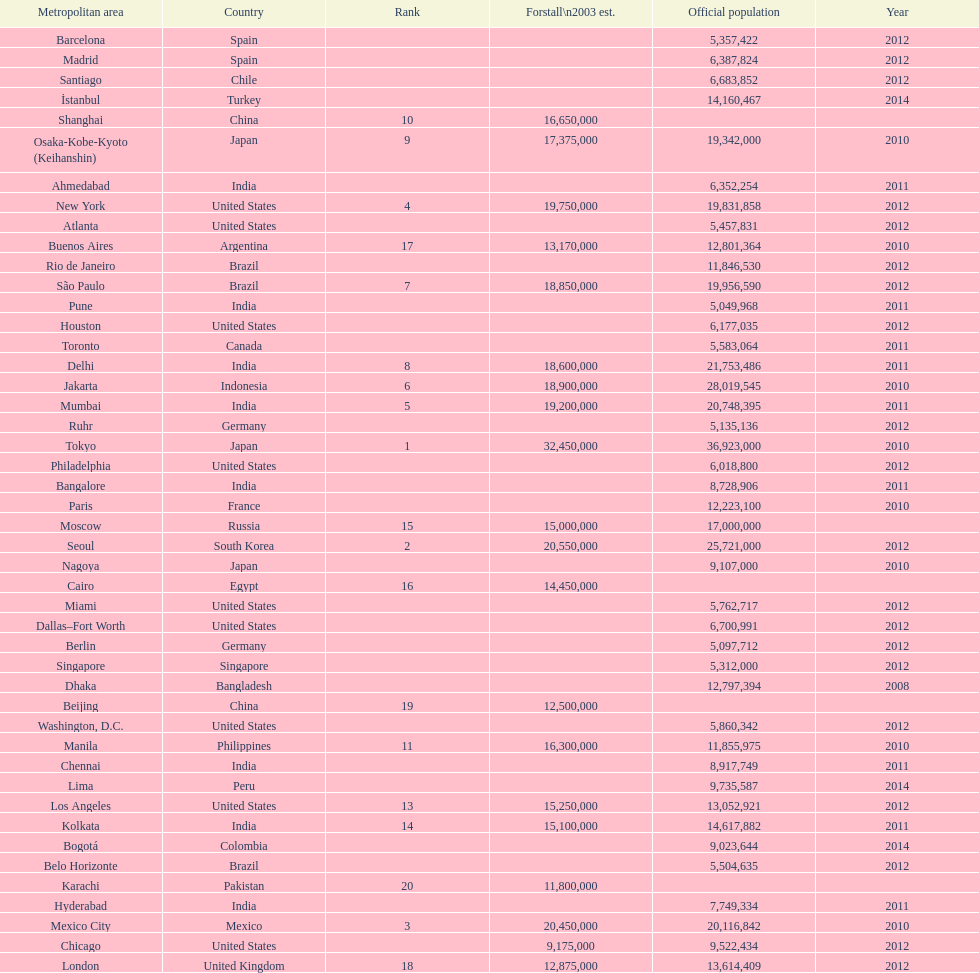What is the population listed immediately before 5,357,422? 8,728,906. 